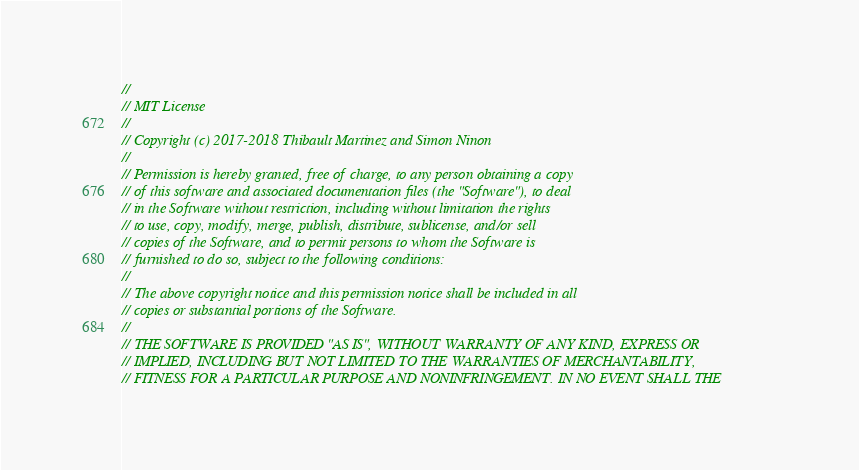Convert code to text. <code><loc_0><loc_0><loc_500><loc_500><_C++_>//
// MIT License
//
// Copyright (c) 2017-2018 Thibault Martinez and Simon Ninon
//
// Permission is hereby granted, free of charge, to any person obtaining a copy
// of this software and associated documentation files (the "Software"), to deal
// in the Software without restriction, including without limitation the rights
// to use, copy, modify, merge, publish, distribute, sublicense, and/or sell
// copies of the Software, and to permit persons to whom the Software is
// furnished to do so, subject to the following conditions:
//
// The above copyright notice and this permission notice shall be included in all
// copies or substantial portions of the Software.
//
// THE SOFTWARE IS PROVIDED "AS IS", WITHOUT WARRANTY OF ANY KIND, EXPRESS OR
// IMPLIED, INCLUDING BUT NOT LIMITED TO THE WARRANTIES OF MERCHANTABILITY,
// FITNESS FOR A PARTICULAR PURPOSE AND NONINFRINGEMENT. IN NO EVENT SHALL THE</code> 